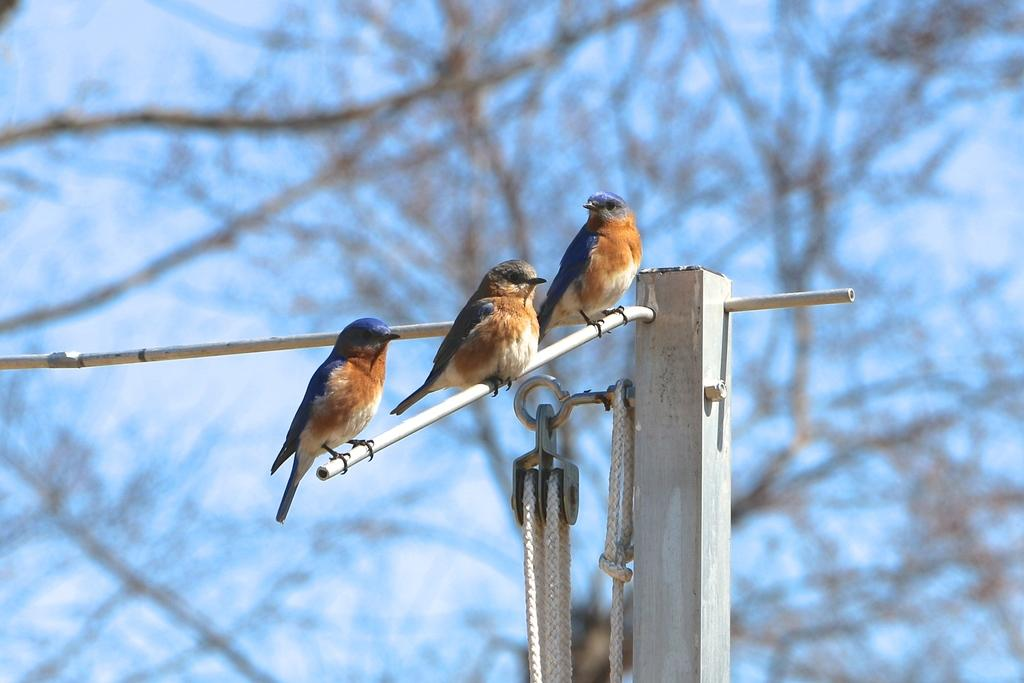What is the main object in the image? There is a wooden pole in the image. What is attached to the wooden pole? Three birds are sitting on a stick attached to the pole. How is the background of the image depicted? The background of the pole is blurred. How many children are playing with the sponge in the image? There are no children or sponge present in the image. What type of tiger can be seen interacting with the birds on the pole? There is no tiger present in the image; only the wooden pole, stick, and birds are visible. 